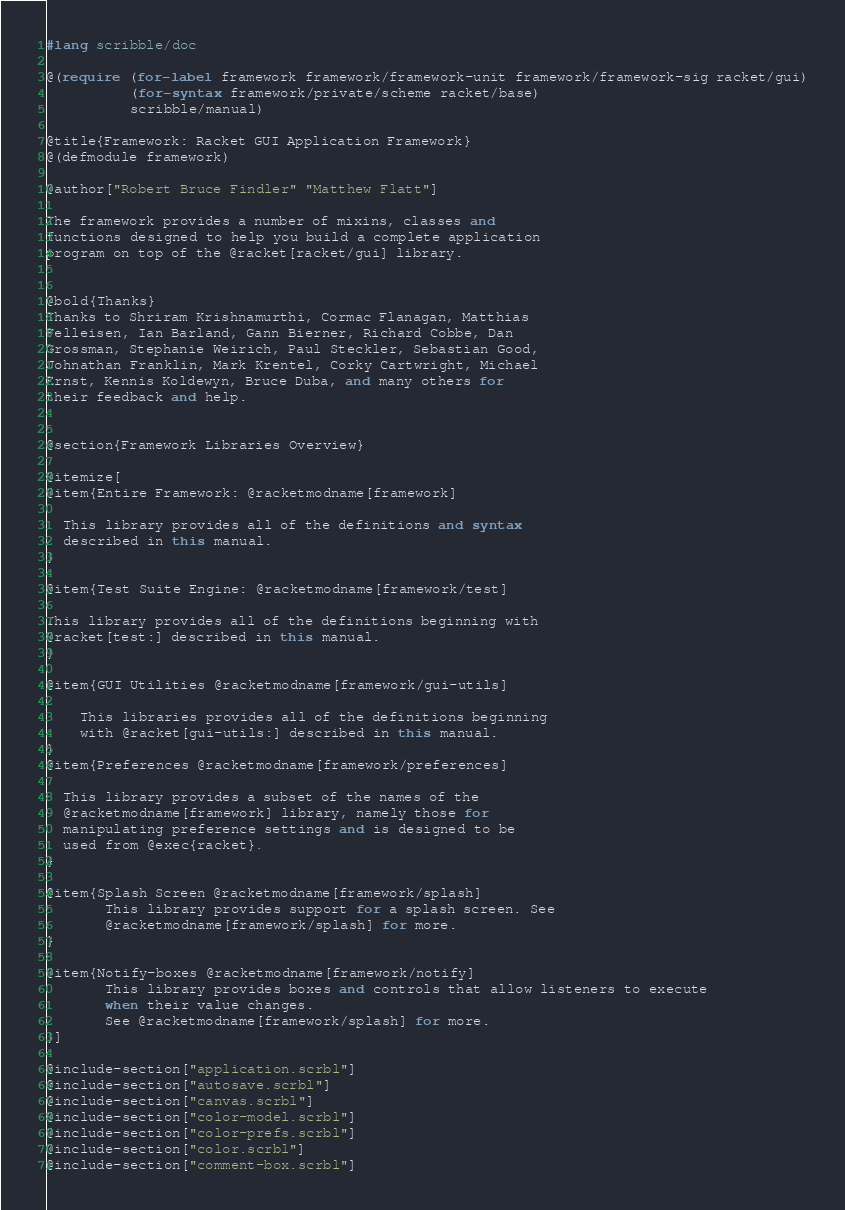Convert code to text. <code><loc_0><loc_0><loc_500><loc_500><_Racket_>#lang scribble/doc

@(require (for-label framework framework/framework-unit framework/framework-sig racket/gui)
          (for-syntax framework/private/scheme racket/base)
          scribble/manual)

@title{Framework: Racket GUI Application Framework}
@(defmodule framework)

@author["Robert Bruce Findler" "Matthew Flatt"]

The framework provides a number of mixins, classes and
functions designed to help you build a complete application
program on top of the @racket[racket/gui] library.


@bold{Thanks}
Thanks to Shriram Krishnamurthi, Cormac Flanagan, Matthias
Felleisen, Ian Barland, Gann Bierner, Richard Cobbe, Dan
Grossman, Stephanie Weirich, Paul Steckler, Sebastian Good,
Johnathan Franklin, Mark Krentel, Corky Cartwright, Michael
Ernst, Kennis Koldewyn, Bruce Duba, and many others for
their feedback and help.


@section{Framework Libraries Overview}

@itemize[
@item{Entire Framework: @racketmodname[framework]

  This library provides all of the definitions and syntax
  described in this manual.
}
 
@item{Test Suite Engine: @racketmodname[framework/test]

This library provides all of the definitions beginning with
@racket[test:] described in this manual.
}

@item{GUI Utilities @racketmodname[framework/gui-utils]

    This libraries provides all of the definitions beginning
    with @racket[gui-utils:] described in this manual.
}
@item{Preferences @racketmodname[framework/preferences]
    
  This library provides a subset of the names of the
  @racketmodname[framework] library, namely those for
  manipulating preference settings and is designed to be
  used from @exec{racket}.
}

@item{Splash Screen @racketmodname[framework/splash]  
       This library provides support for a splash screen. See
       @racketmodname[framework/splash] for more.
}

@item{Notify-boxes @racketmodname[framework/notify]
       This library provides boxes and controls that allow listeners to execute
       when their value changes.
       See @racketmodname[framework/splash] for more.
}]

@include-section["application.scrbl"]
@include-section["autosave.scrbl"]
@include-section["canvas.scrbl"]
@include-section["color-model.scrbl"]
@include-section["color-prefs.scrbl"]
@include-section["color.scrbl"]
@include-section["comment-box.scrbl"]
</code> 